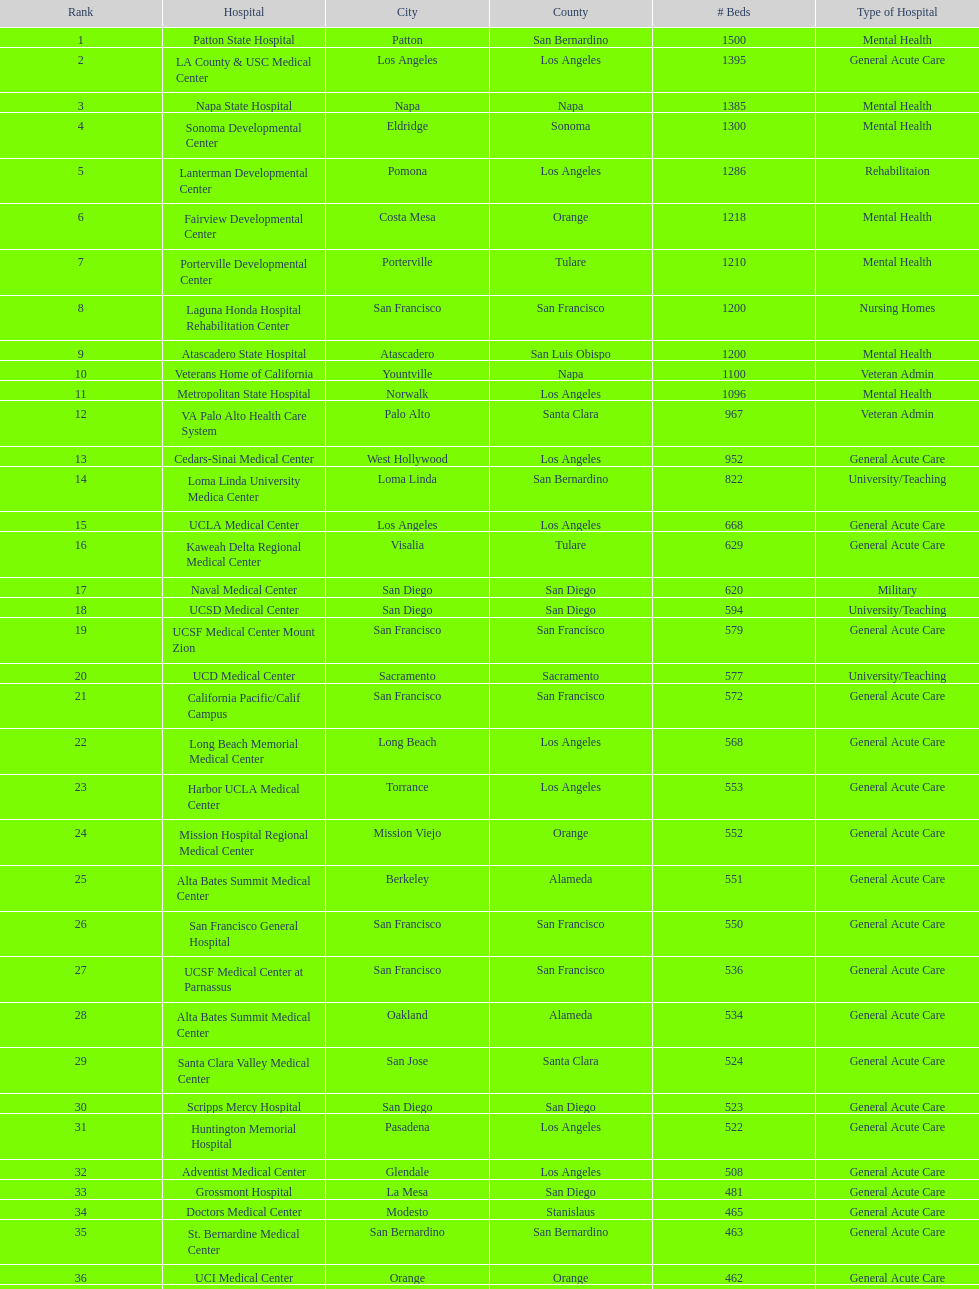What hospital in los angeles county providing hospital beds specifically for rehabilitation is ranked at least among the top 10 hospitals? Lanterman Developmental Center. 